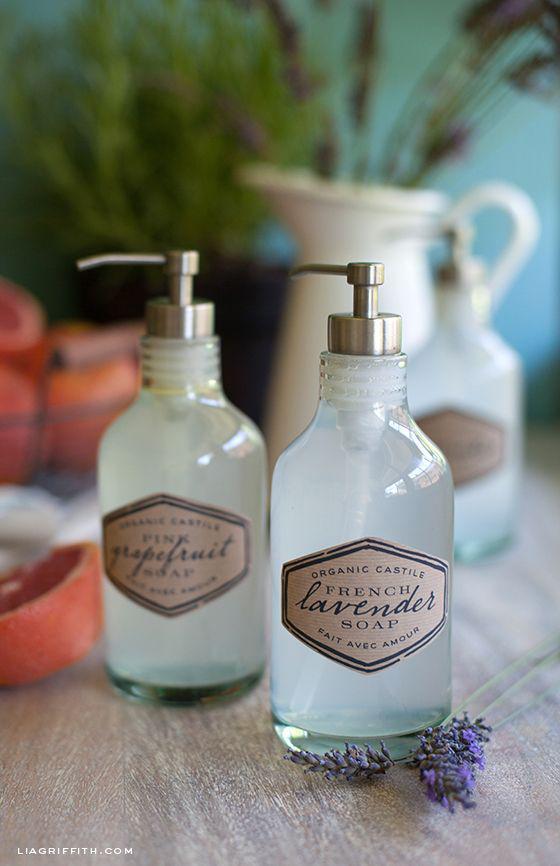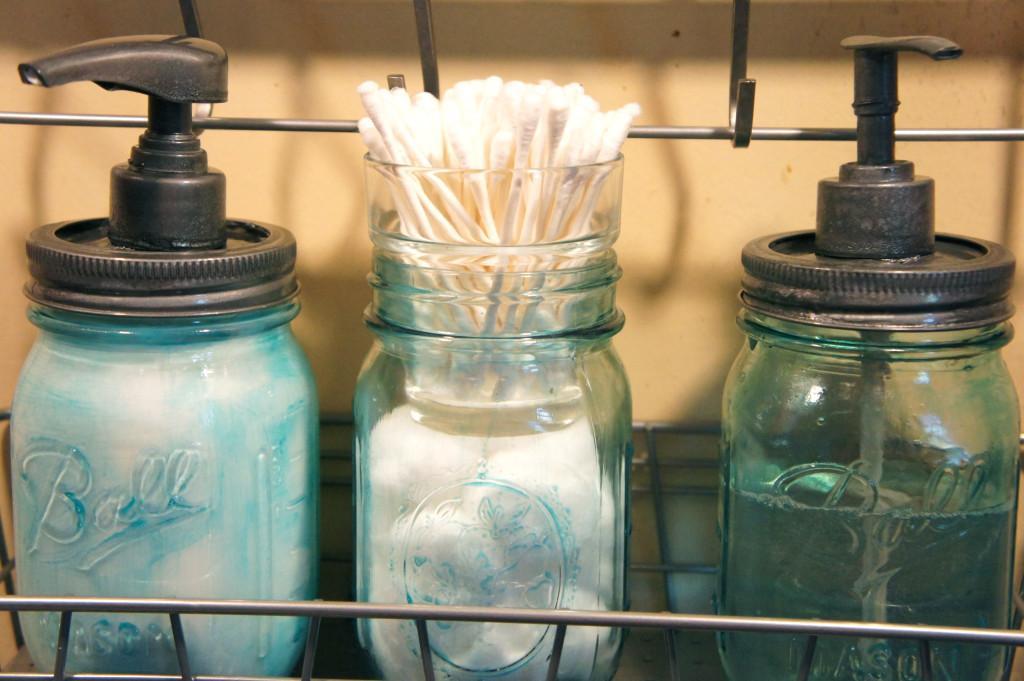The first image is the image on the left, the second image is the image on the right. Evaluate the accuracy of this statement regarding the images: "A lone dispenser has some green soap in it.". Is it true? Answer yes or no. No. 